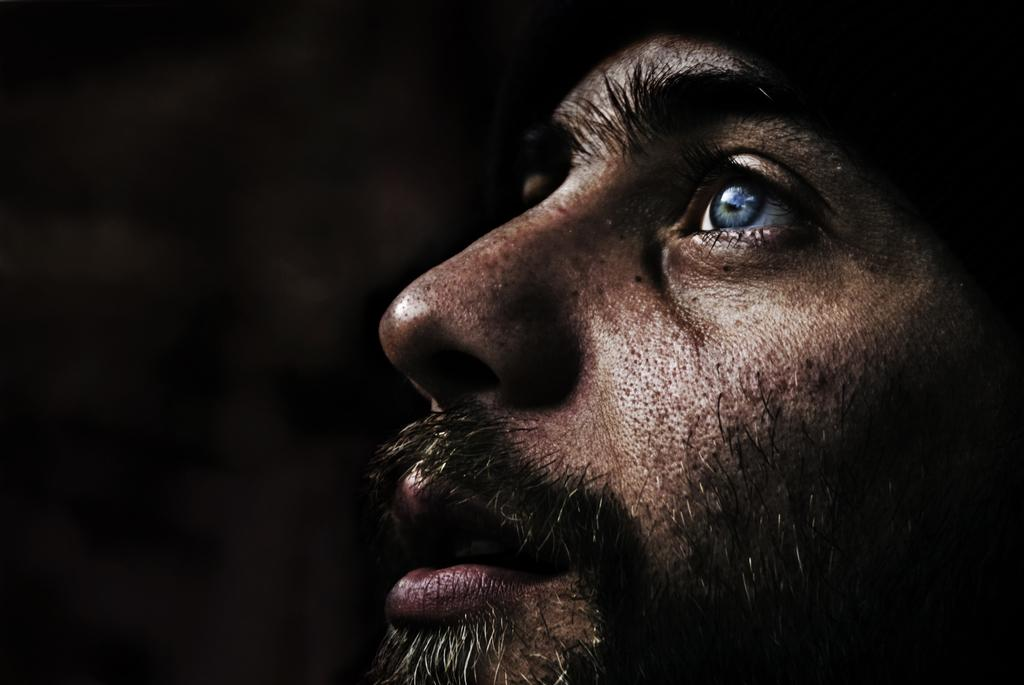Who is present in the image? There is a man in the image. Can you describe the lighting in the image? The left side of the image is dark. What type of toothpaste is the man using in the image? There is no toothpaste present in the image. What adjustments is the man making to his clothing in the image? There is no indication in the image that the man is making any adjustments to his clothing. 